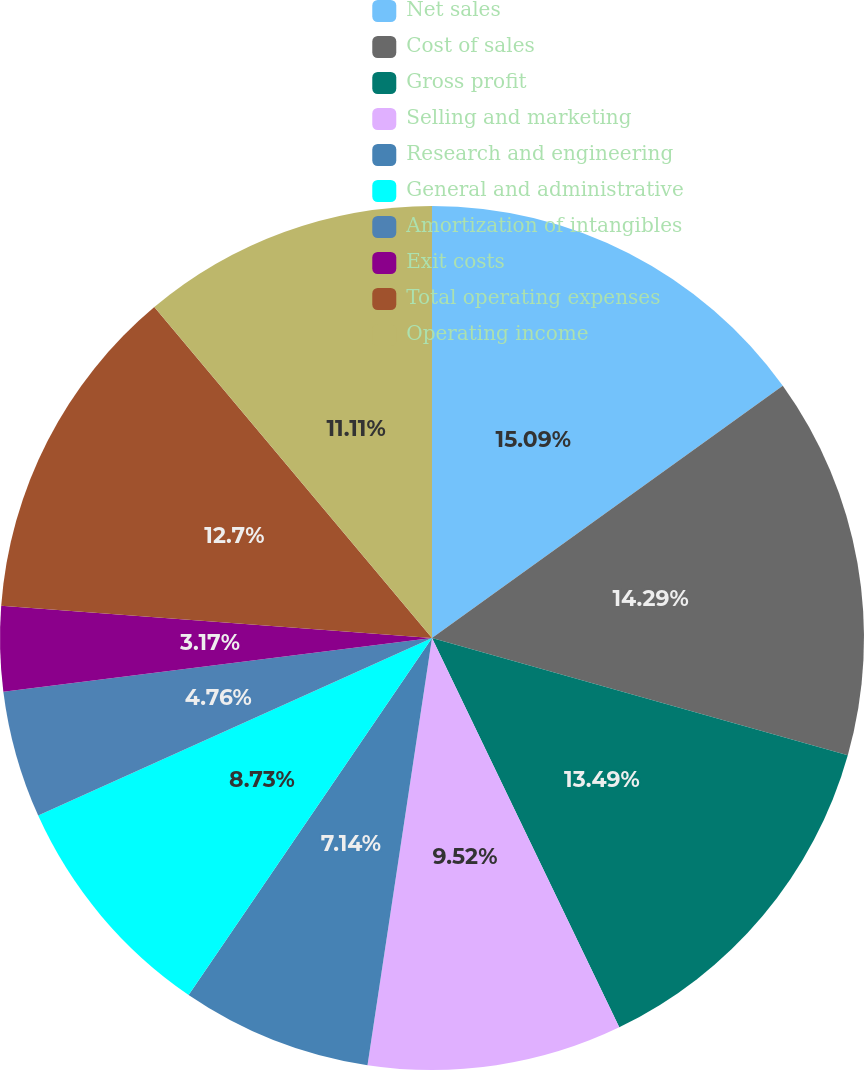Convert chart. <chart><loc_0><loc_0><loc_500><loc_500><pie_chart><fcel>Net sales<fcel>Cost of sales<fcel>Gross profit<fcel>Selling and marketing<fcel>Research and engineering<fcel>General and administrative<fcel>Amortization of intangibles<fcel>Exit costs<fcel>Total operating expenses<fcel>Operating income<nl><fcel>15.08%<fcel>14.29%<fcel>13.49%<fcel>9.52%<fcel>7.14%<fcel>8.73%<fcel>4.76%<fcel>3.17%<fcel>12.7%<fcel>11.11%<nl></chart> 